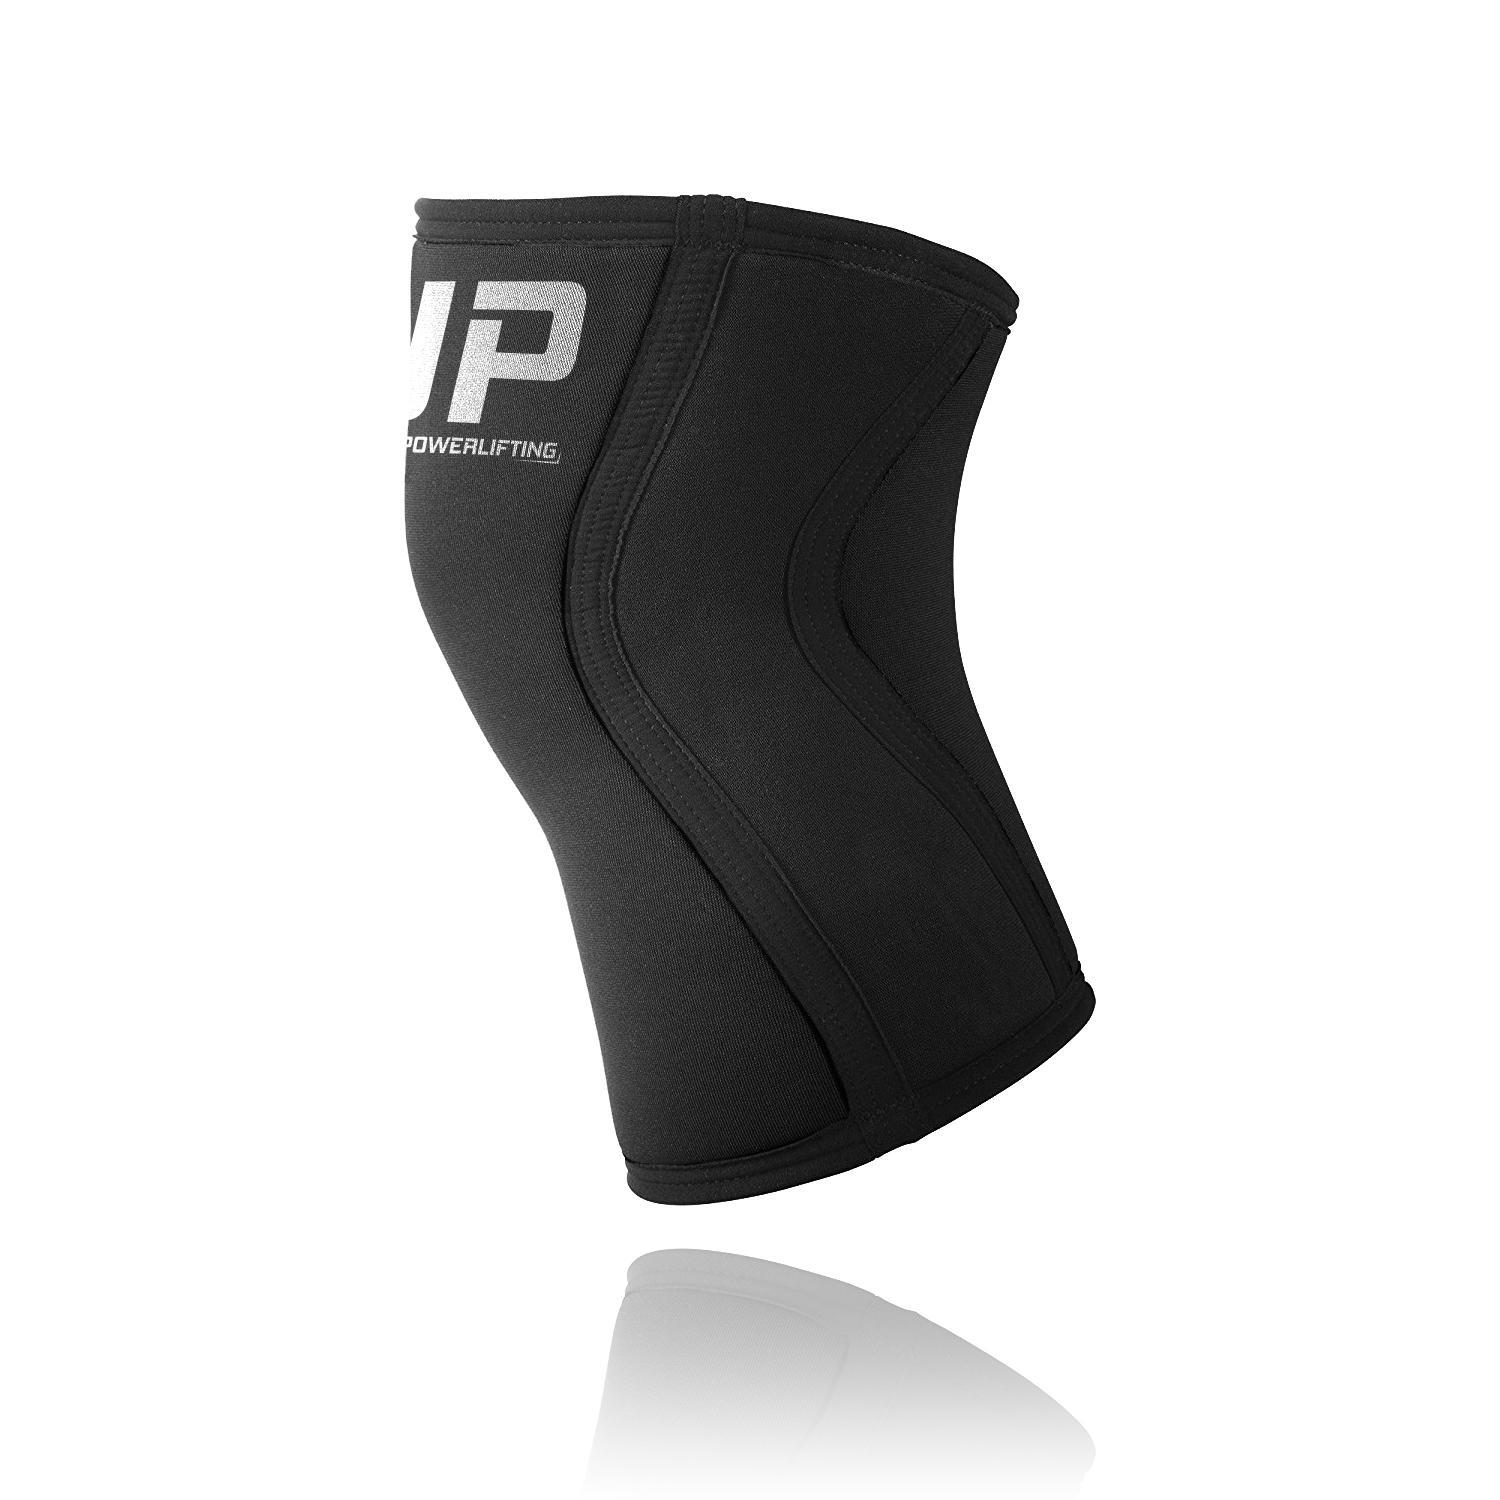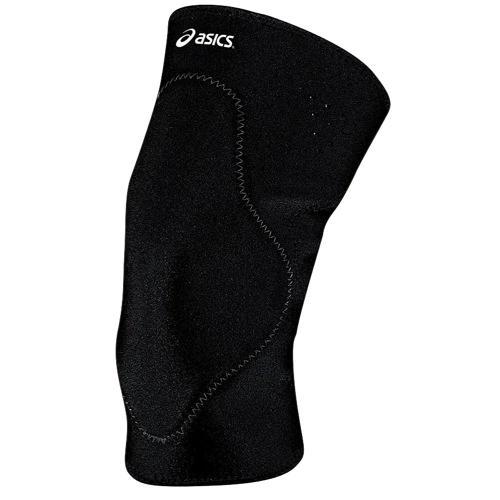The first image is the image on the left, the second image is the image on the right. For the images shown, is this caption "The knee pad is turned to the right in the image on the right." true? Answer yes or no. No. 